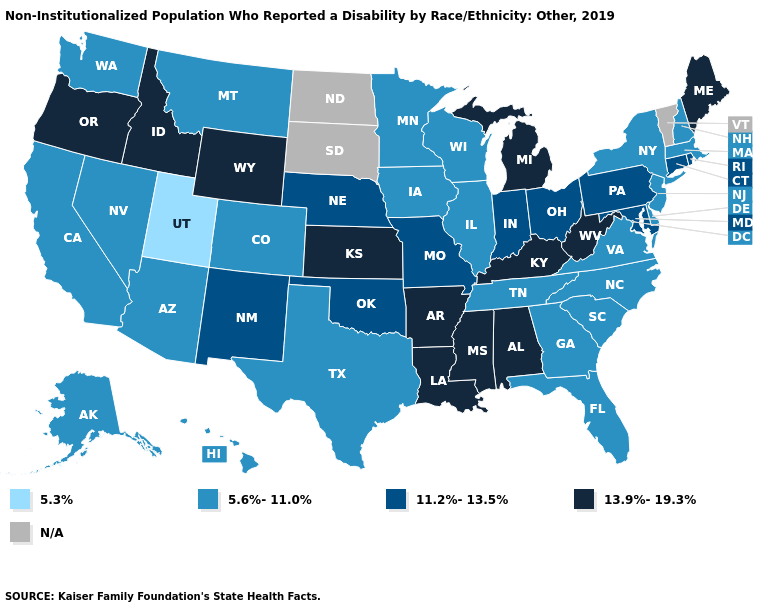Does Utah have the lowest value in the USA?
Short answer required. Yes. What is the lowest value in the South?
Be succinct. 5.6%-11.0%. What is the lowest value in the Northeast?
Give a very brief answer. 5.6%-11.0%. What is the lowest value in states that border Mississippi?
Keep it brief. 5.6%-11.0%. What is the highest value in states that border Ohio?
Concise answer only. 13.9%-19.3%. Does Oregon have the lowest value in the West?
Quick response, please. No. Name the states that have a value in the range 13.9%-19.3%?
Concise answer only. Alabama, Arkansas, Idaho, Kansas, Kentucky, Louisiana, Maine, Michigan, Mississippi, Oregon, West Virginia, Wyoming. Name the states that have a value in the range 13.9%-19.3%?
Answer briefly. Alabama, Arkansas, Idaho, Kansas, Kentucky, Louisiana, Maine, Michigan, Mississippi, Oregon, West Virginia, Wyoming. Name the states that have a value in the range N/A?
Quick response, please. North Dakota, South Dakota, Vermont. Name the states that have a value in the range 13.9%-19.3%?
Quick response, please. Alabama, Arkansas, Idaho, Kansas, Kentucky, Louisiana, Maine, Michigan, Mississippi, Oregon, West Virginia, Wyoming. Name the states that have a value in the range N/A?
Short answer required. North Dakota, South Dakota, Vermont. Which states have the highest value in the USA?
Answer briefly. Alabama, Arkansas, Idaho, Kansas, Kentucky, Louisiana, Maine, Michigan, Mississippi, Oregon, West Virginia, Wyoming. What is the lowest value in the USA?
Be succinct. 5.3%. Does Kentucky have the lowest value in the South?
Be succinct. No. 